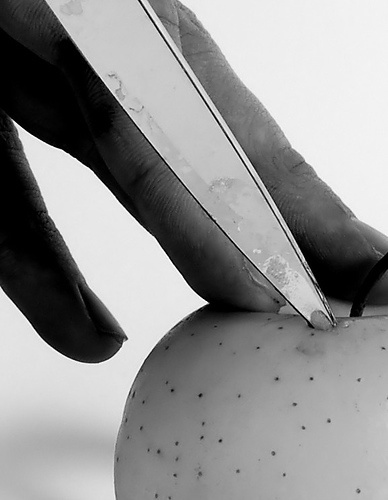Describe the objects in this image and their specific colors. I can see people in black, gray, and lightgray tones, apple in black, darkgray, gray, and lightgray tones, and knife in black, lightgray, darkgray, and gray tones in this image. 